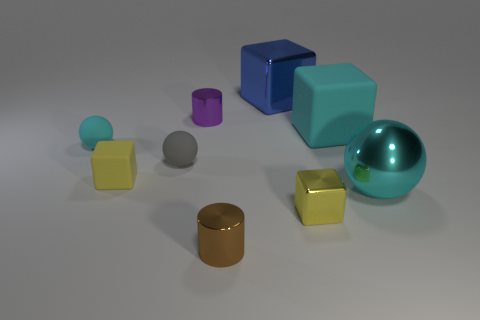What number of other objects are there of the same shape as the large blue shiny thing?
Make the answer very short. 3. Are there any other things that are made of the same material as the gray sphere?
Provide a short and direct response. Yes. The small metal cylinder that is in front of the large block that is in front of the large shiny thing that is on the left side of the large sphere is what color?
Give a very brief answer. Brown. Do the cyan rubber thing left of the large blue metallic thing and the brown metallic thing have the same shape?
Your answer should be very brief. No. What number of small yellow rubber blocks are there?
Your answer should be very brief. 1. What number of cyan shiny spheres have the same size as the blue metallic cube?
Offer a terse response. 1. What material is the blue object?
Provide a succinct answer. Metal. Does the large matte cube have the same color as the cylinder that is left of the small brown shiny cylinder?
Keep it short and to the point. No. Is there anything else that is the same size as the brown metallic cylinder?
Your response must be concise. Yes. What size is the metallic thing that is left of the big blue thing and behind the big shiny ball?
Offer a very short reply. Small. 